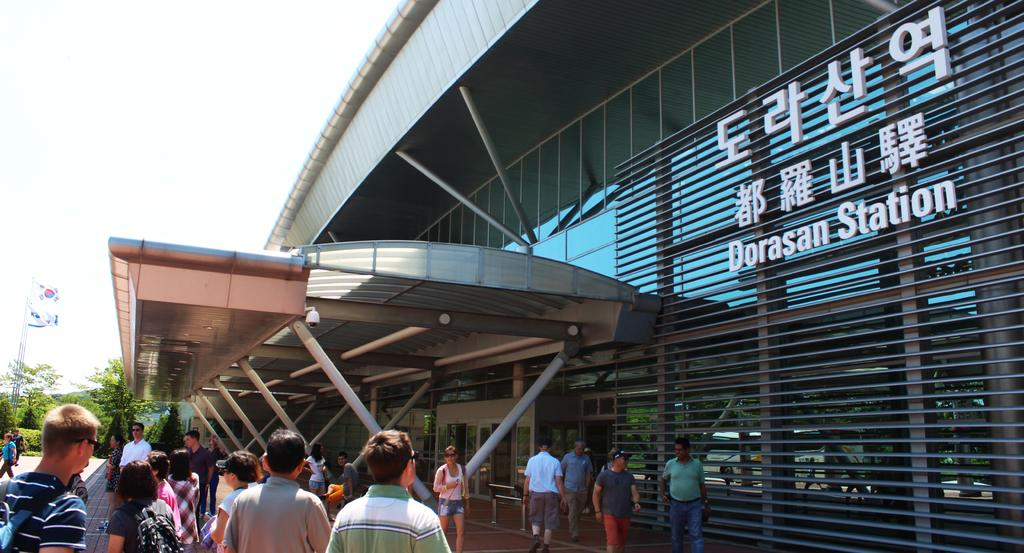What is happening in front of the building in the image? There are groups of people standing in front of a building. What can be seen on a pole in the image? There is a flag on a pole. What type of natural elements are visible in the image? There are trees visible in the image. How many bikes are parked near the groups of people in the image? There is no mention of bikes in the image, so it is not possible to determine how many bikes might be present. 